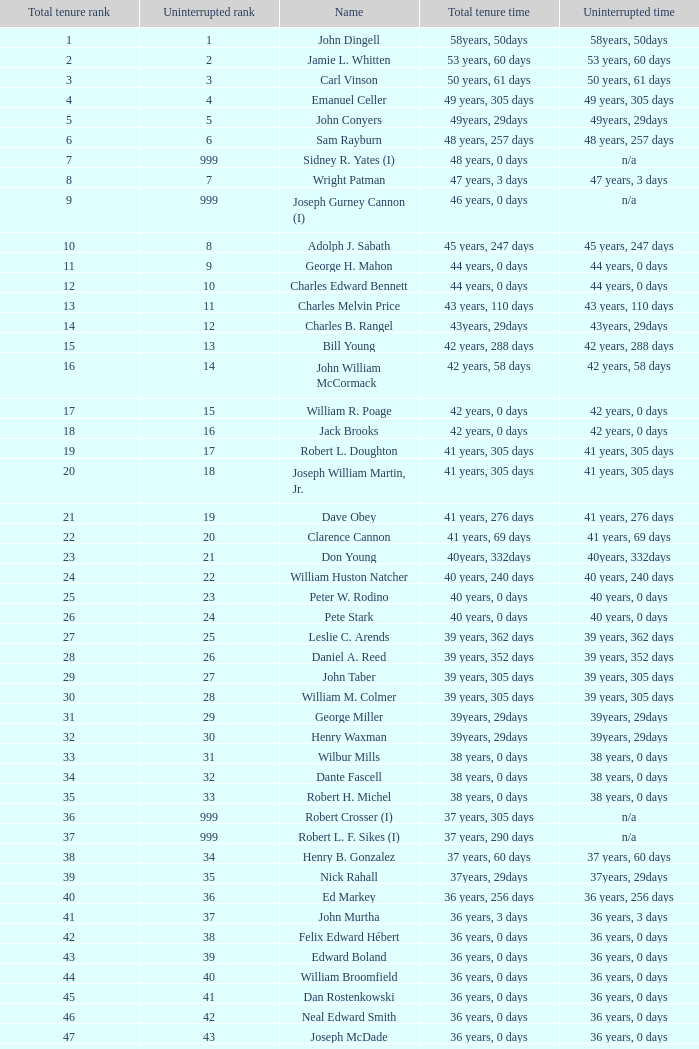Who has a total tenure time and uninterrupted time of 36 years, 0 days, as well as a total tenure rank of 49? James Oberstar. Would you be able to parse every entry in this table? {'header': ['Total tenure rank', 'Uninterrupted rank', 'Name', 'Total tenure time', 'Uninterrupted time'], 'rows': [['1', '1', 'John Dingell', '58years, 50days', '58years, 50days'], ['2', '2', 'Jamie L. Whitten', '53 years, 60 days', '53 years, 60 days'], ['3', '3', 'Carl Vinson', '50 years, 61 days', '50 years, 61 days'], ['4', '4', 'Emanuel Celler', '49 years, 305 days', '49 years, 305 days'], ['5', '5', 'John Conyers', '49years, 29days', '49years, 29days'], ['6', '6', 'Sam Rayburn', '48 years, 257 days', '48 years, 257 days'], ['7', '999', 'Sidney R. Yates (I)', '48 years, 0 days', 'n/a'], ['8', '7', 'Wright Patman', '47 years, 3 days', '47 years, 3 days'], ['9', '999', 'Joseph Gurney Cannon (I)', '46 years, 0 days', 'n/a'], ['10', '8', 'Adolph J. Sabath', '45 years, 247 days', '45 years, 247 days'], ['11', '9', 'George H. Mahon', '44 years, 0 days', '44 years, 0 days'], ['12', '10', 'Charles Edward Bennett', '44 years, 0 days', '44 years, 0 days'], ['13', '11', 'Charles Melvin Price', '43 years, 110 days', '43 years, 110 days'], ['14', '12', 'Charles B. Rangel', '43years, 29days', '43years, 29days'], ['15', '13', 'Bill Young', '42 years, 288 days', '42 years, 288 days'], ['16', '14', 'John William McCormack', '42 years, 58 days', '42 years, 58 days'], ['17', '15', 'William R. Poage', '42 years, 0 days', '42 years, 0 days'], ['18', '16', 'Jack Brooks', '42 years, 0 days', '42 years, 0 days'], ['19', '17', 'Robert L. Doughton', '41 years, 305 days', '41 years, 305 days'], ['20', '18', 'Joseph William Martin, Jr.', '41 years, 305 days', '41 years, 305 days'], ['21', '19', 'Dave Obey', '41 years, 276 days', '41 years, 276 days'], ['22', '20', 'Clarence Cannon', '41 years, 69 days', '41 years, 69 days'], ['23', '21', 'Don Young', '40years, 332days', '40years, 332days'], ['24', '22', 'William Huston Natcher', '40 years, 240 days', '40 years, 240 days'], ['25', '23', 'Peter W. Rodino', '40 years, 0 days', '40 years, 0 days'], ['26', '24', 'Pete Stark', '40 years, 0 days', '40 years, 0 days'], ['27', '25', 'Leslie C. Arends', '39 years, 362 days', '39 years, 362 days'], ['28', '26', 'Daniel A. Reed', '39 years, 352 days', '39 years, 352 days'], ['29', '27', 'John Taber', '39 years, 305 days', '39 years, 305 days'], ['30', '28', 'William M. Colmer', '39 years, 305 days', '39 years, 305 days'], ['31', '29', 'George Miller', '39years, 29days', '39years, 29days'], ['32', '30', 'Henry Waxman', '39years, 29days', '39years, 29days'], ['33', '31', 'Wilbur Mills', '38 years, 0 days', '38 years, 0 days'], ['34', '32', 'Dante Fascell', '38 years, 0 days', '38 years, 0 days'], ['35', '33', 'Robert H. Michel', '38 years, 0 days', '38 years, 0 days'], ['36', '999', 'Robert Crosser (I)', '37 years, 305 days', 'n/a'], ['37', '999', 'Robert L. F. Sikes (I)', '37 years, 290 days', 'n/a'], ['38', '34', 'Henry B. Gonzalez', '37 years, 60 days', '37 years, 60 days'], ['39', '35', 'Nick Rahall', '37years, 29days', '37years, 29days'], ['40', '36', 'Ed Markey', '36 years, 256 days', '36 years, 256 days'], ['41', '37', 'John Murtha', '36 years, 3 days', '36 years, 3 days'], ['42', '38', 'Felix Edward Hébert', '36 years, 0 days', '36 years, 0 days'], ['43', '39', 'Edward Boland', '36 years, 0 days', '36 years, 0 days'], ['44', '40', 'William Broomfield', '36 years, 0 days', '36 years, 0 days'], ['45', '41', 'Dan Rostenkowski', '36 years, 0 days', '36 years, 0 days'], ['46', '42', 'Neal Edward Smith', '36 years, 0 days', '36 years, 0 days'], ['47', '43', 'Joseph McDade', '36 years, 0 days', '36 years, 0 days'], ['48', '44', 'Ralph Regula', '36 years, 0 days', '36 years, 0 days'], ['49', '45', 'James Oberstar', '36 years, 0 days', '36 years, 0 days'], ['50', '46', 'Norman D. Dicks', '36 years, 0 days', '36 years, 0 days'], ['51', '47', 'Dale Kildee', '36 years, 0 days', '36 years, 0 days'], ['52', '999', 'Henry A. Cooper (I)', '36 years, 0 days', 'n/a']]} 